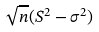<formula> <loc_0><loc_0><loc_500><loc_500>\sqrt { n } ( S ^ { 2 } - \sigma ^ { 2 } )</formula> 